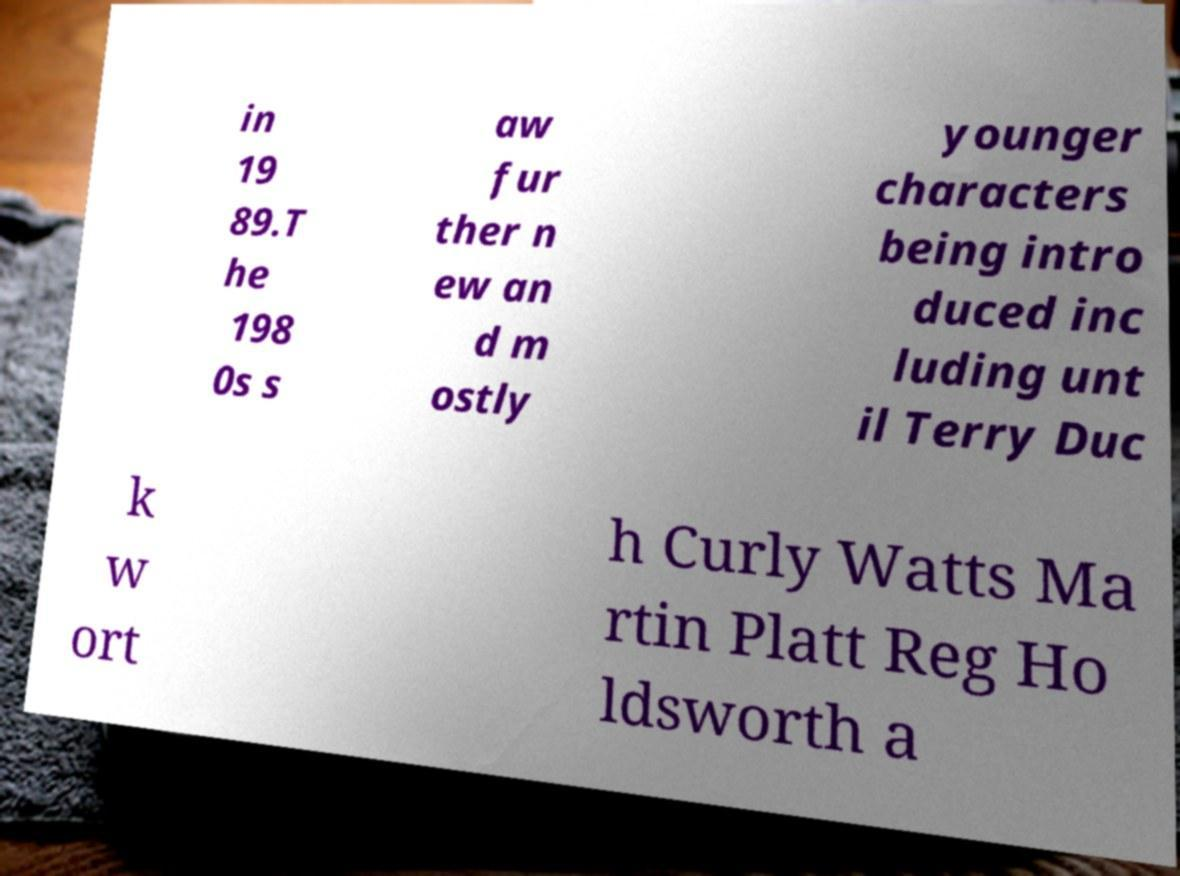Can you accurately transcribe the text from the provided image for me? in 19 89.T he 198 0s s aw fur ther n ew an d m ostly younger characters being intro duced inc luding unt il Terry Duc k w ort h Curly Watts Ma rtin Platt Reg Ho ldsworth a 